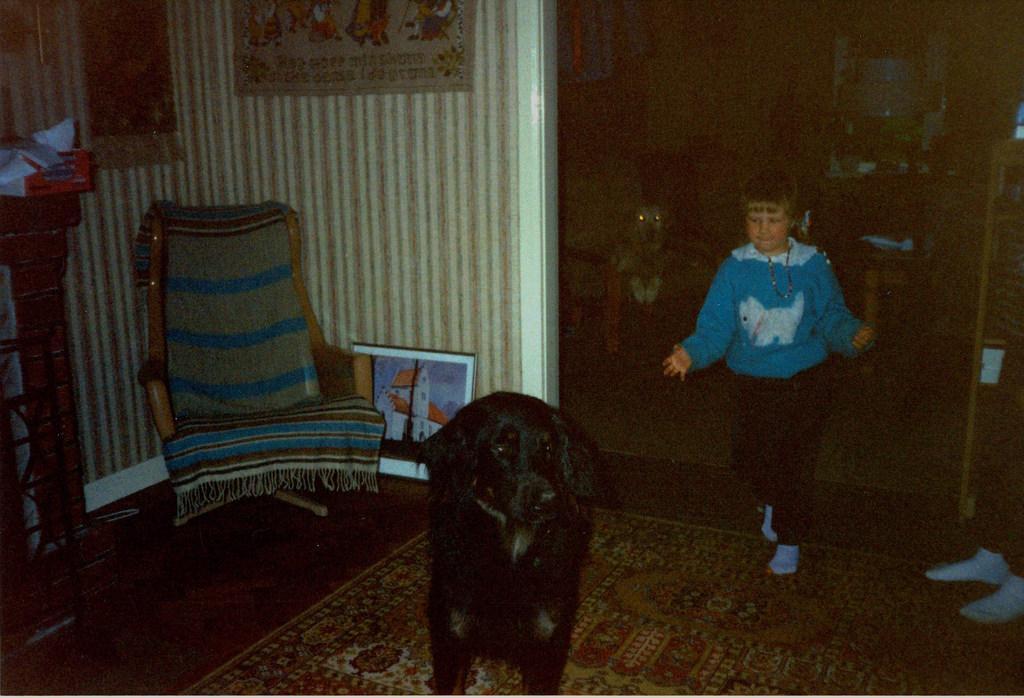Please provide a concise description of this image. in a room there is a black dog. behind the dog a person is standing, he is wearing a blue t shirt. at the left there is a chair and below that a photo frame is kept on the floor. at the back there is another dog. at the right a person's legs are appearing. 